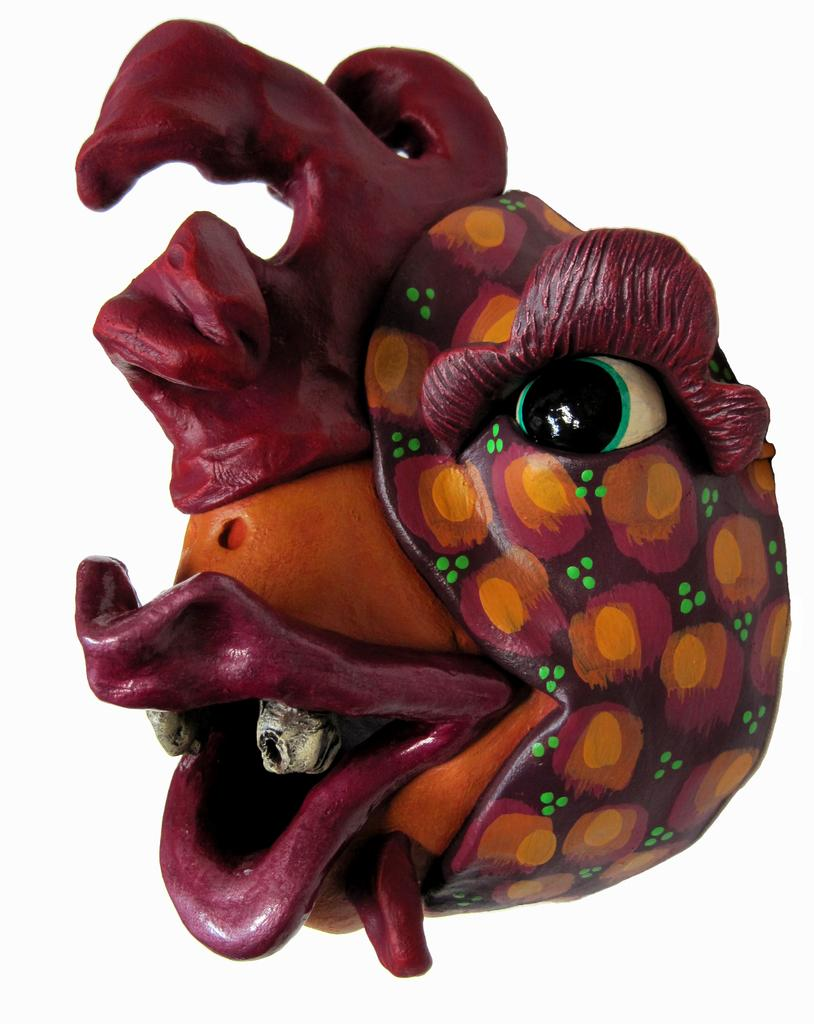What is the main subject of the image? There is some kind of art in the image. What color is the background of the image? The background of the image is white. What type of agreement did the dad sign in the image? There is no dad or agreement present in the image. What kind of fowl can be seen in the image? There is no fowl present in the image. 